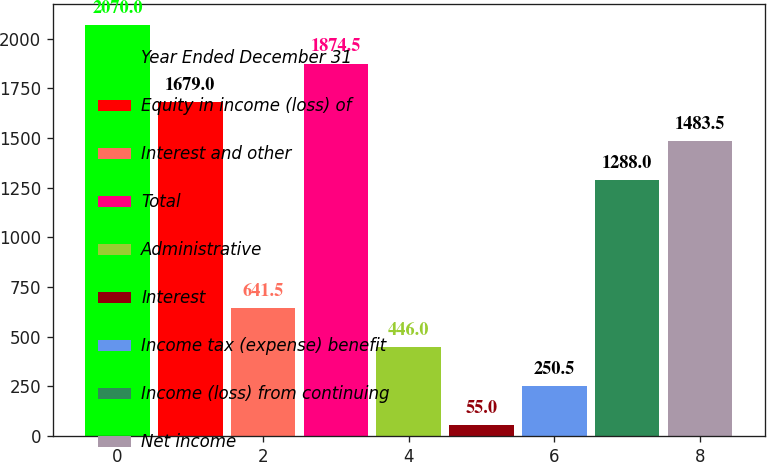Convert chart. <chart><loc_0><loc_0><loc_500><loc_500><bar_chart><fcel>Year Ended December 31<fcel>Equity in income (loss) of<fcel>Interest and other<fcel>Total<fcel>Administrative<fcel>Interest<fcel>Income tax (expense) benefit<fcel>Income (loss) from continuing<fcel>Net income<nl><fcel>2070<fcel>1679<fcel>641.5<fcel>1874.5<fcel>446<fcel>55<fcel>250.5<fcel>1288<fcel>1483.5<nl></chart> 